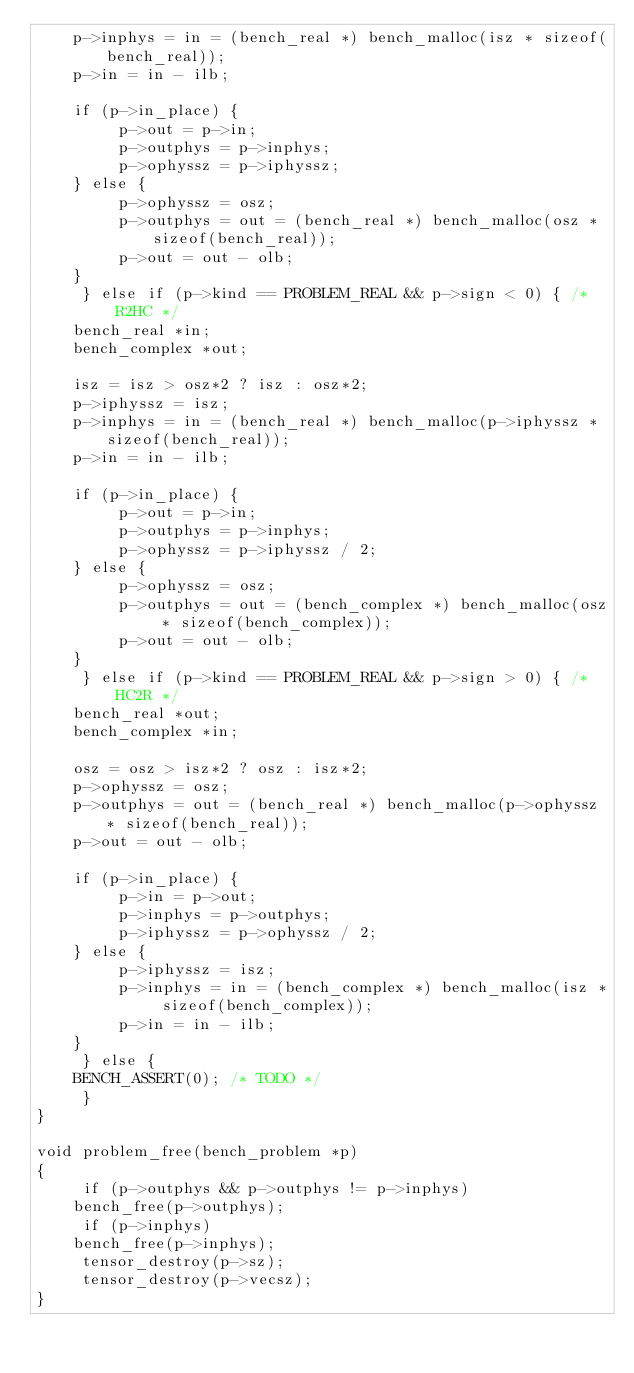<code> <loc_0><loc_0><loc_500><loc_500><_C_>	  p->inphys = in = (bench_real *) bench_malloc(isz * sizeof(bench_real));
	  p->in = in - ilb;
	  
	  if (p->in_place) {
	       p->out = p->in;
	       p->outphys = p->inphys;
	       p->ophyssz = p->iphyssz;
	  } else {
	       p->ophyssz = osz;
	       p->outphys = out = (bench_real *) bench_malloc(osz * sizeof(bench_real));
	       p->out = out - olb;
	  }
     } else if (p->kind == PROBLEM_REAL && p->sign < 0) { /* R2HC */
	  bench_real *in;
	  bench_complex *out;

	  isz = isz > osz*2 ? isz : osz*2;
	  p->iphyssz = isz;
	  p->inphys = in = (bench_real *) bench_malloc(p->iphyssz * sizeof(bench_real));
	  p->in = in - ilb;
	  
	  if (p->in_place) {
	       p->out = p->in;
	       p->outphys = p->inphys;
	       p->ophyssz = p->iphyssz / 2;
	  } else {
	       p->ophyssz = osz;
	       p->outphys = out = (bench_complex *) bench_malloc(osz * sizeof(bench_complex));
	       p->out = out - olb;
	  }
     } else if (p->kind == PROBLEM_REAL && p->sign > 0) { /* HC2R */
	  bench_real *out;
	  bench_complex *in;

	  osz = osz > isz*2 ? osz : isz*2;
	  p->ophyssz = osz;
	  p->outphys = out = (bench_real *) bench_malloc(p->ophyssz * sizeof(bench_real));
	  p->out = out - olb;
	  
	  if (p->in_place) {
	       p->in = p->out;
	       p->inphys = p->outphys;
	       p->iphyssz = p->ophyssz / 2;
	  } else {
	       p->iphyssz = isz;
	       p->inphys = in = (bench_complex *) bench_malloc(isz * sizeof(bench_complex));
	       p->in = in - ilb;
	  }
     } else {
	  BENCH_ASSERT(0); /* TODO */
     }
}

void problem_free(bench_problem *p)
{
     if (p->outphys && p->outphys != p->inphys)
	  bench_free(p->outphys);
     if (p->inphys)
	  bench_free(p->inphys);
     tensor_destroy(p->sz);
     tensor_destroy(p->vecsz);
}
</code> 